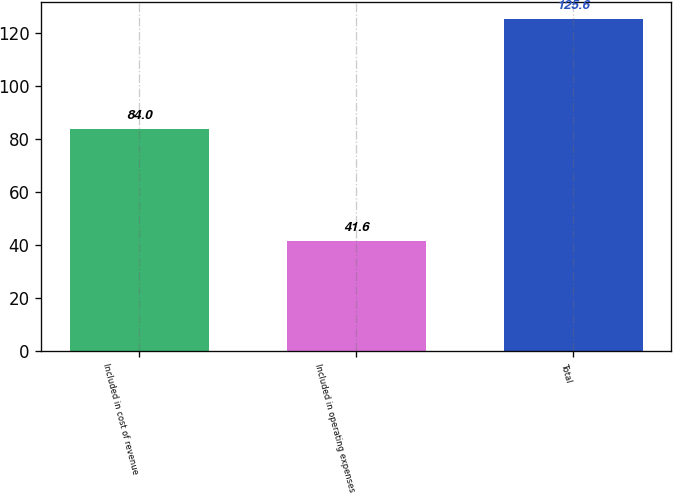Convert chart. <chart><loc_0><loc_0><loc_500><loc_500><bar_chart><fcel>Included in cost of revenue<fcel>Included in operating expenses<fcel>Total<nl><fcel>84<fcel>41.6<fcel>125.6<nl></chart> 